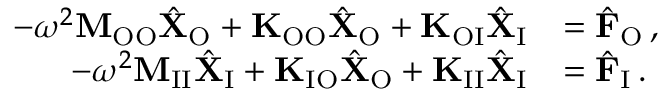<formula> <loc_0><loc_0><loc_500><loc_500>\begin{array} { r l } { - \omega ^ { 2 } M _ { O O } \hat { X } _ { O } + K _ { O O } \hat { X } _ { O } + K _ { O I } \hat { X } _ { I } } & { = \hat { F } _ { O } \, , } \\ { - \omega ^ { 2 } M _ { I I } \hat { X } _ { I } + K _ { I O } \hat { X } _ { O } + K _ { I I } \hat { X } _ { I } } & { = \hat { F } _ { I } \, . } \end{array}</formula> 